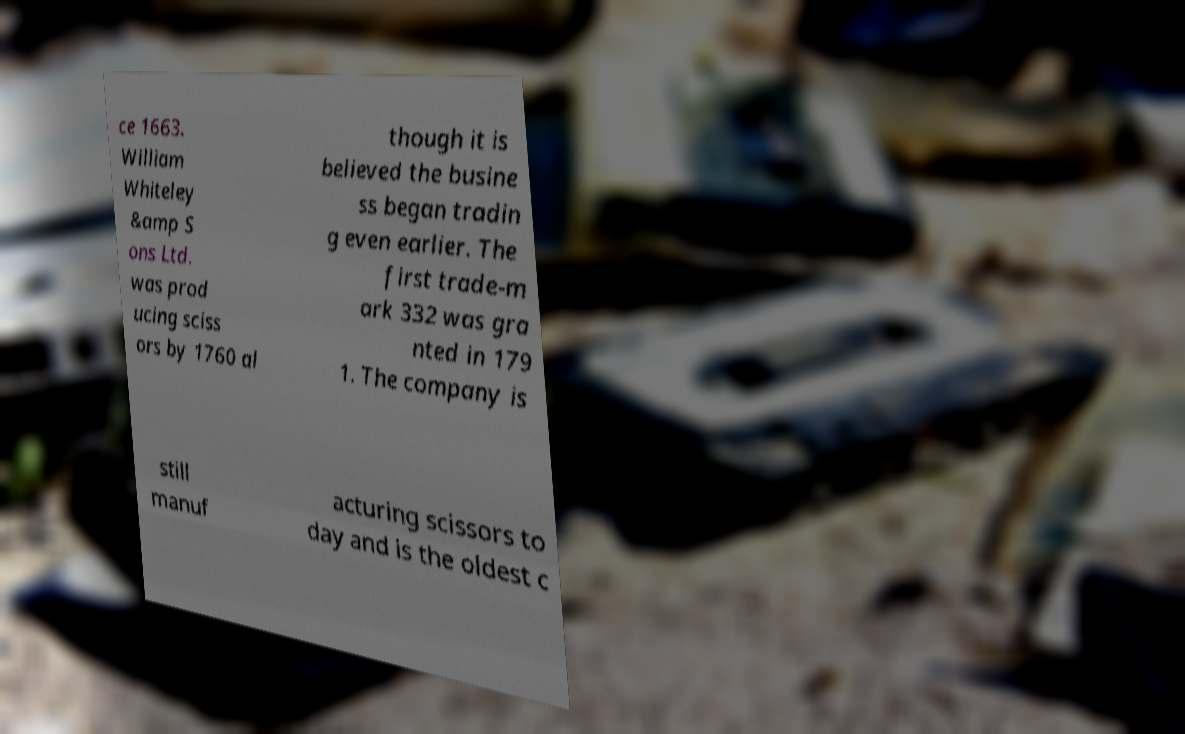Could you extract and type out the text from this image? ce 1663. William Whiteley &amp S ons Ltd. was prod ucing sciss ors by 1760 al though it is believed the busine ss began tradin g even earlier. The first trade-m ark 332 was gra nted in 179 1. The company is still manuf acturing scissors to day and is the oldest c 